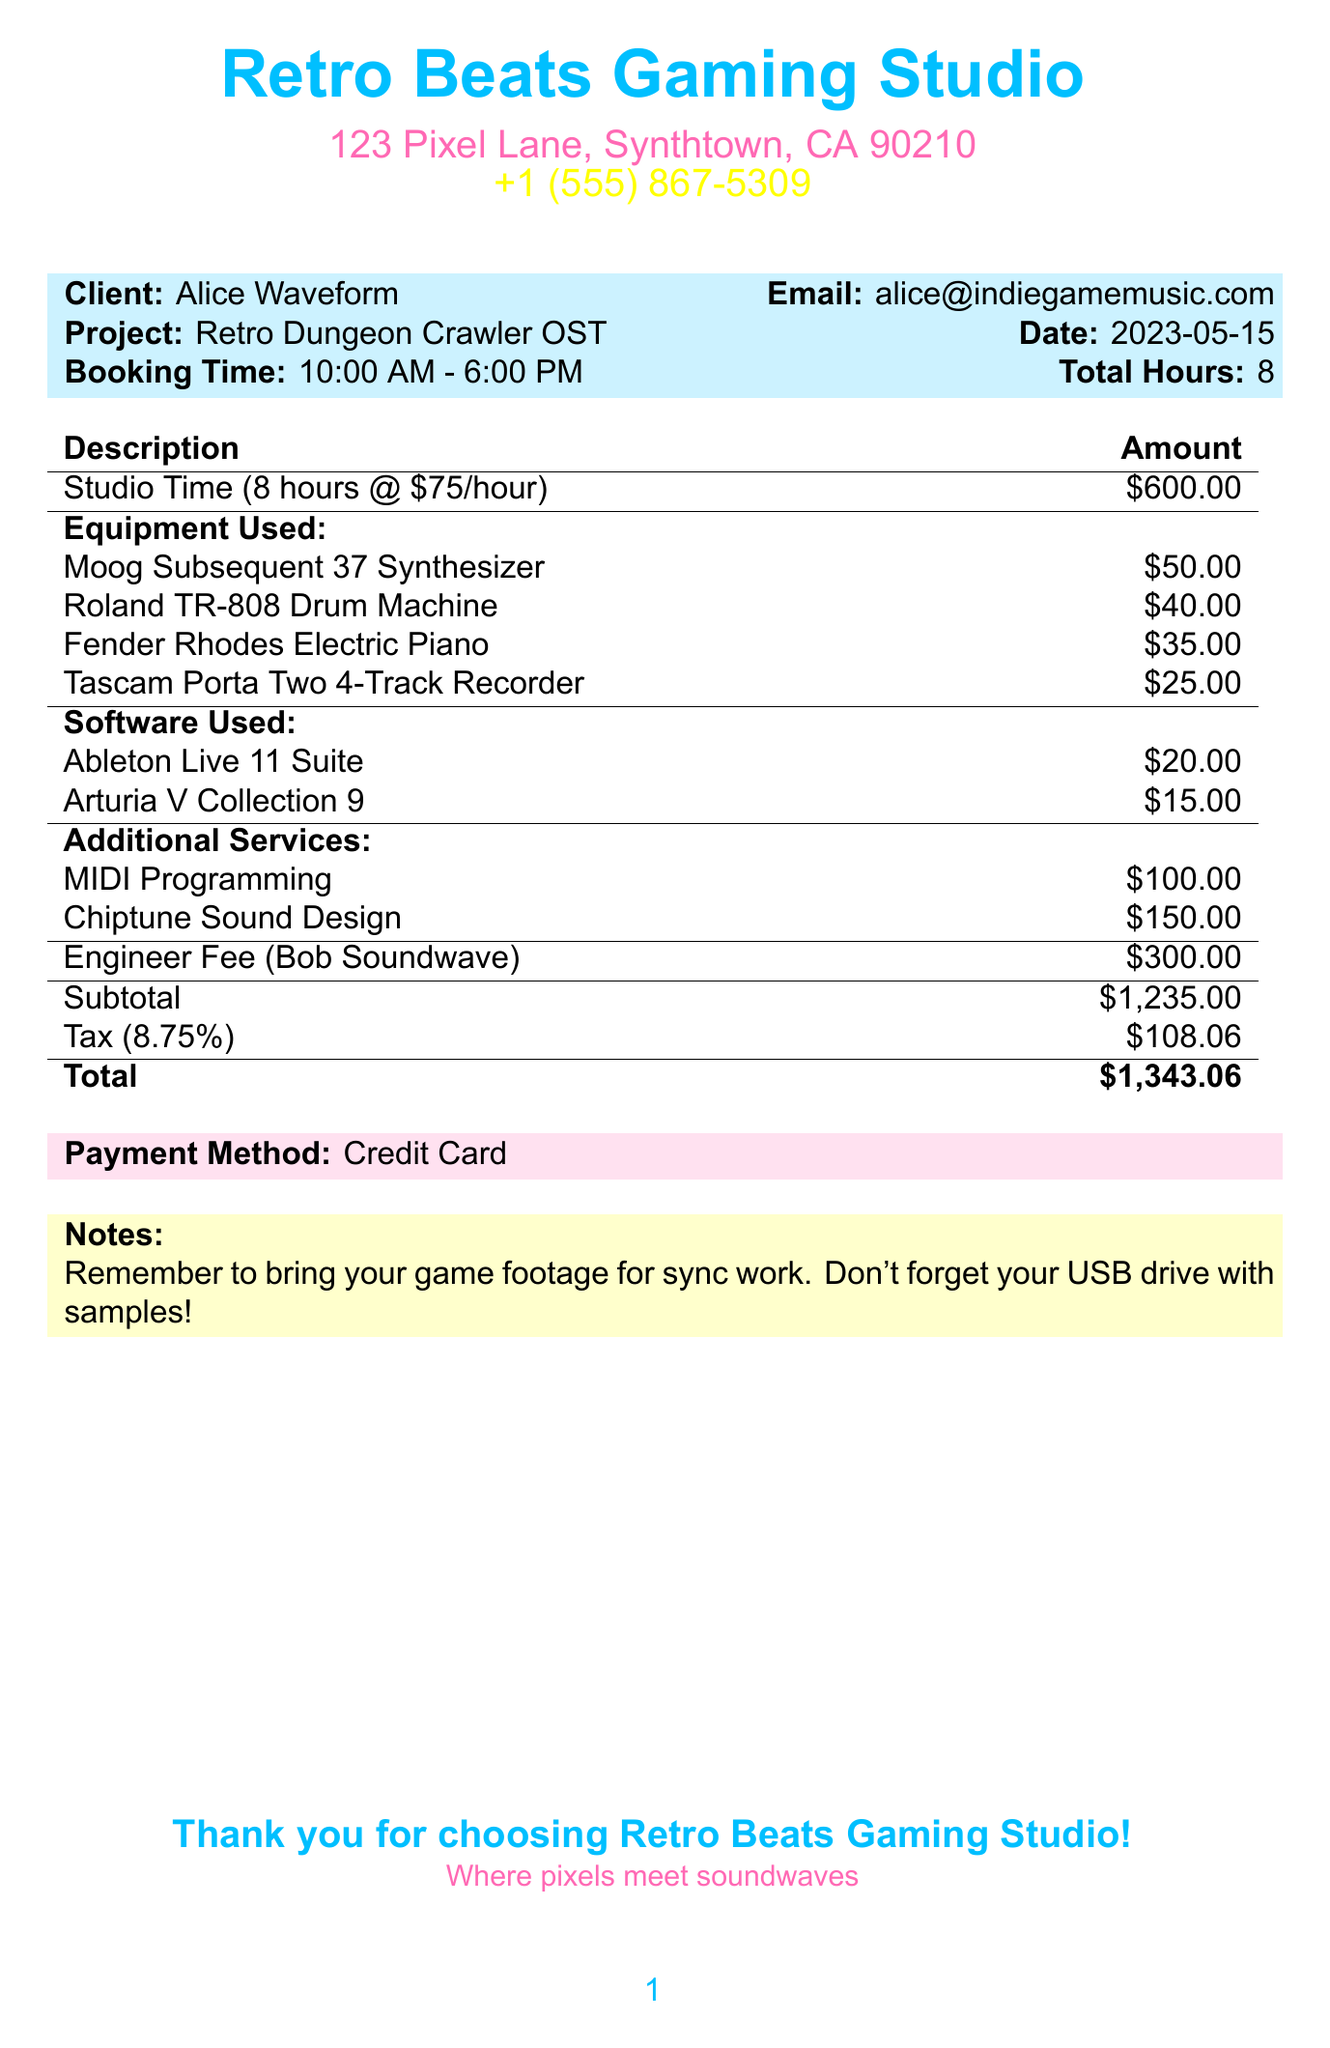What is the total hours booked? The total hours booked is explicitly stated in the document under total hours.
Answer: 8 What is the name of the studio? The name of the studio is provided at the start of the document.
Answer: Retro Beats Gaming Studio Who is the engineer for this booking? The engineer's name is mentioned in the engineer fee section.
Answer: Bob Soundwave What is the hourly rate for studio time? The hourly rate is listed in the studio time description on the receipt.
Answer: 75 What is the rental fee for the Moog Subsequent 37 Synthesizer? The rental fee for the Moog Subsequent 37 Synthesizer is detailed in the equipment used section.
Answer: 50 How much was paid for additional services? The total for additional services is the sum of the fees listed under additional services.
Answer: 250 What is the tax amount charged? The tax amount is specified in the subtotal section of the document.
Answer: 108.06 What is the project name? The project name is stated near the top of the document.
Answer: Retro Dungeon Crawler OST What payment method was used? The payment method is indicated at the bottom of the document.
Answer: Credit Card 